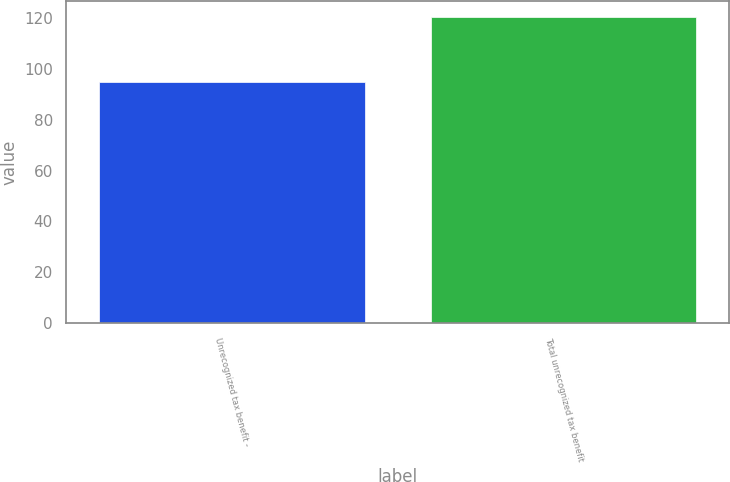Convert chart to OTSL. <chart><loc_0><loc_0><loc_500><loc_500><bar_chart><fcel>Unrecognized tax benefit -<fcel>Total unrecognized tax benefit<nl><fcel>94.9<fcel>120.7<nl></chart> 